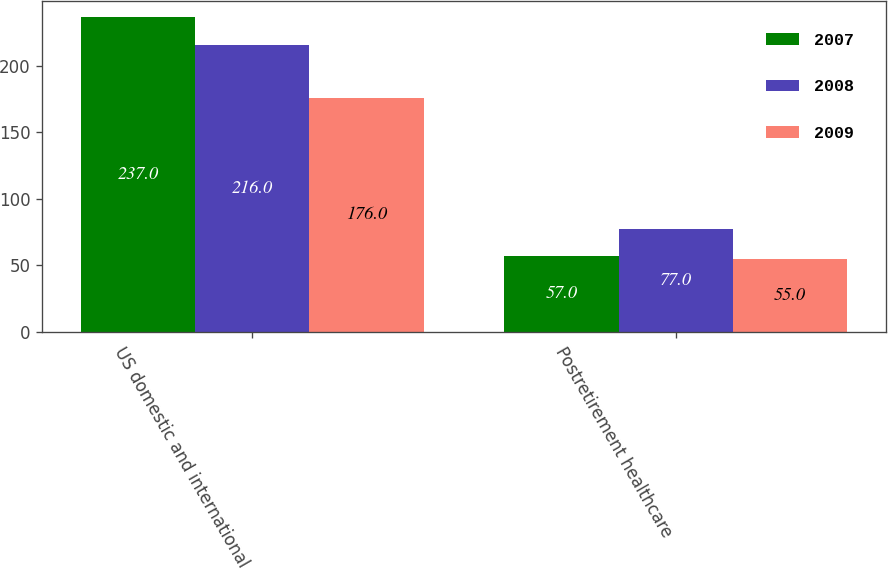<chart> <loc_0><loc_0><loc_500><loc_500><stacked_bar_chart><ecel><fcel>US domestic and international<fcel>Postretirement healthcare<nl><fcel>2007<fcel>237<fcel>57<nl><fcel>2008<fcel>216<fcel>77<nl><fcel>2009<fcel>176<fcel>55<nl></chart> 